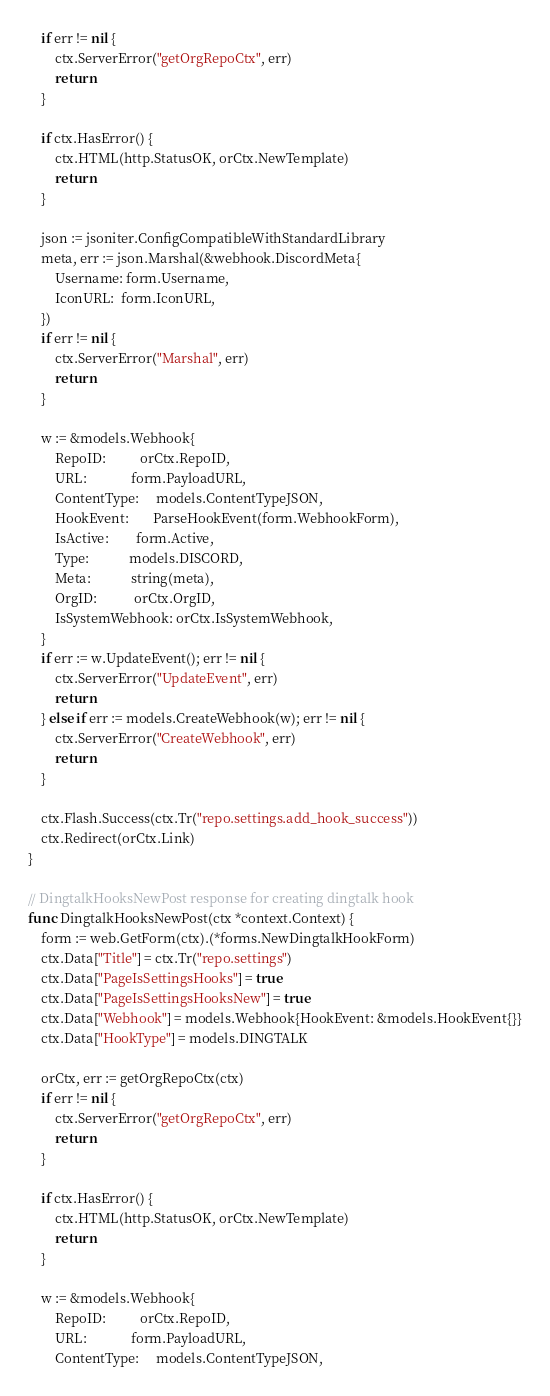Convert code to text. <code><loc_0><loc_0><loc_500><loc_500><_Go_>	if err != nil {
		ctx.ServerError("getOrgRepoCtx", err)
		return
	}

	if ctx.HasError() {
		ctx.HTML(http.StatusOK, orCtx.NewTemplate)
		return
	}

	json := jsoniter.ConfigCompatibleWithStandardLibrary
	meta, err := json.Marshal(&webhook.DiscordMeta{
		Username: form.Username,
		IconURL:  form.IconURL,
	})
	if err != nil {
		ctx.ServerError("Marshal", err)
		return
	}

	w := &models.Webhook{
		RepoID:          orCtx.RepoID,
		URL:             form.PayloadURL,
		ContentType:     models.ContentTypeJSON,
		HookEvent:       ParseHookEvent(form.WebhookForm),
		IsActive:        form.Active,
		Type:            models.DISCORD,
		Meta:            string(meta),
		OrgID:           orCtx.OrgID,
		IsSystemWebhook: orCtx.IsSystemWebhook,
	}
	if err := w.UpdateEvent(); err != nil {
		ctx.ServerError("UpdateEvent", err)
		return
	} else if err := models.CreateWebhook(w); err != nil {
		ctx.ServerError("CreateWebhook", err)
		return
	}

	ctx.Flash.Success(ctx.Tr("repo.settings.add_hook_success"))
	ctx.Redirect(orCtx.Link)
}

// DingtalkHooksNewPost response for creating dingtalk hook
func DingtalkHooksNewPost(ctx *context.Context) {
	form := web.GetForm(ctx).(*forms.NewDingtalkHookForm)
	ctx.Data["Title"] = ctx.Tr("repo.settings")
	ctx.Data["PageIsSettingsHooks"] = true
	ctx.Data["PageIsSettingsHooksNew"] = true
	ctx.Data["Webhook"] = models.Webhook{HookEvent: &models.HookEvent{}}
	ctx.Data["HookType"] = models.DINGTALK

	orCtx, err := getOrgRepoCtx(ctx)
	if err != nil {
		ctx.ServerError("getOrgRepoCtx", err)
		return
	}

	if ctx.HasError() {
		ctx.HTML(http.StatusOK, orCtx.NewTemplate)
		return
	}

	w := &models.Webhook{
		RepoID:          orCtx.RepoID,
		URL:             form.PayloadURL,
		ContentType:     models.ContentTypeJSON,</code> 